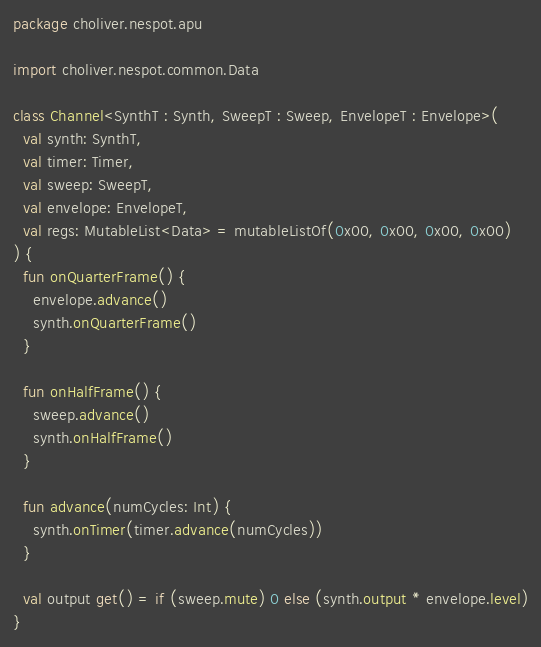Convert code to text. <code><loc_0><loc_0><loc_500><loc_500><_Kotlin_>package choliver.nespot.apu

import choliver.nespot.common.Data

class Channel<SynthT : Synth, SweepT : Sweep, EnvelopeT : Envelope>(
  val synth: SynthT,
  val timer: Timer,
  val sweep: SweepT,
  val envelope: EnvelopeT,
  val regs: MutableList<Data> = mutableListOf(0x00, 0x00, 0x00, 0x00)
) {
  fun onQuarterFrame() {
    envelope.advance()
    synth.onQuarterFrame()
  }

  fun onHalfFrame() {
    sweep.advance()
    synth.onHalfFrame()
  }

  fun advance(numCycles: Int) {
    synth.onTimer(timer.advance(numCycles))
  }

  val output get() = if (sweep.mute) 0 else (synth.output * envelope.level)
}
</code> 